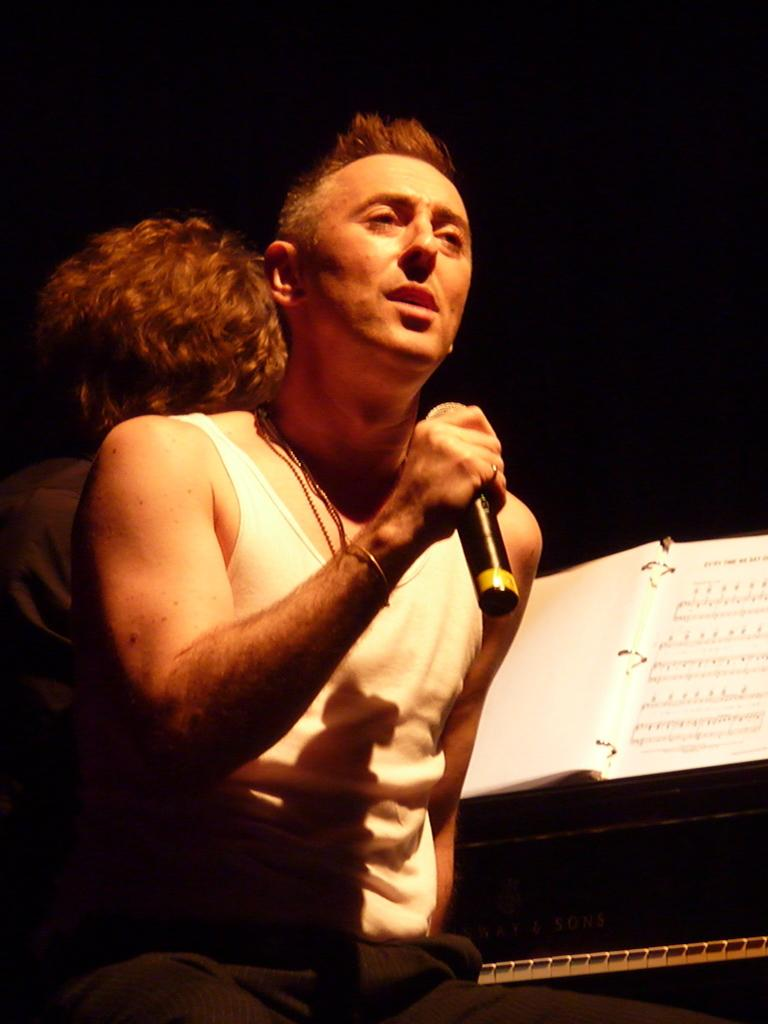What is the man in the image doing? The man is performing in the image. What tool is the man using while performing? The man is using a microphone. Are there any other people involved in the performance? Yes, there is another man playing an instrument in the image. What type of cheese is the man wearing on his badge in the image? There is no cheese or badge present in the image. What color are the trousers the man is wearing while performing? The provided facts do not mention the color of the man's trousers, so we cannot answer this question definitively. 